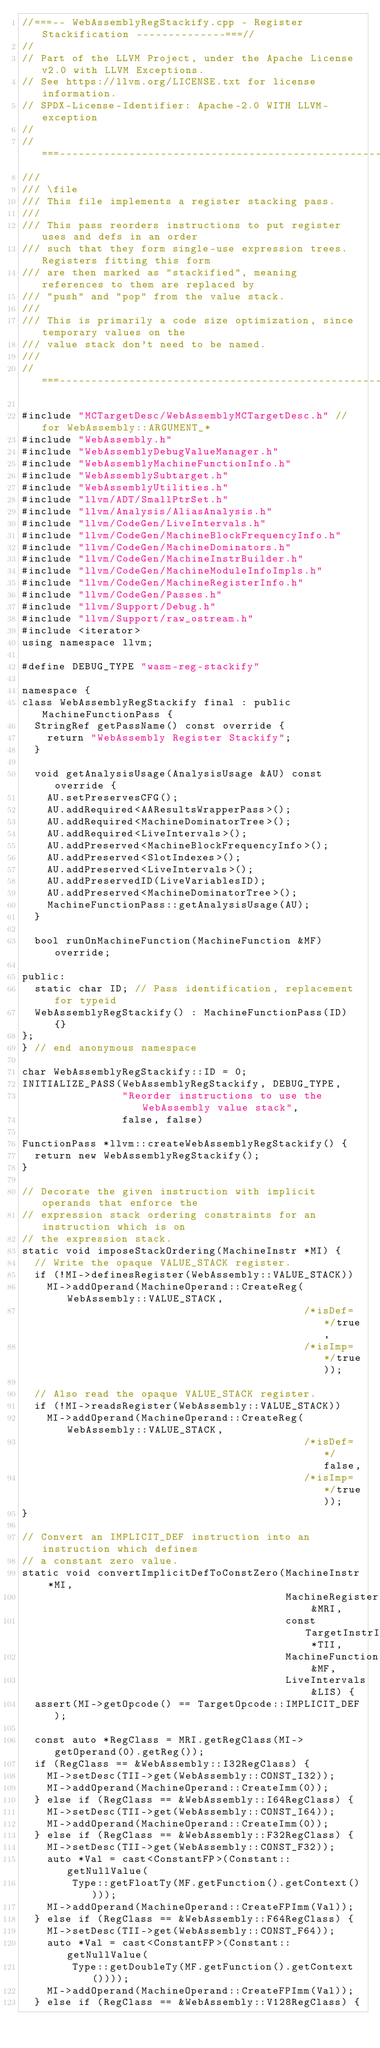Convert code to text. <code><loc_0><loc_0><loc_500><loc_500><_C++_>//===-- WebAssemblyRegStackify.cpp - Register Stackification --------------===//
//
// Part of the LLVM Project, under the Apache License v2.0 with LLVM Exceptions.
// See https://llvm.org/LICENSE.txt for license information.
// SPDX-License-Identifier: Apache-2.0 WITH LLVM-exception
//
//===----------------------------------------------------------------------===//
///
/// \file
/// This file implements a register stacking pass.
///
/// This pass reorders instructions to put register uses and defs in an order
/// such that they form single-use expression trees. Registers fitting this form
/// are then marked as "stackified", meaning references to them are replaced by
/// "push" and "pop" from the value stack.
///
/// This is primarily a code size optimization, since temporary values on the
/// value stack don't need to be named.
///
//===----------------------------------------------------------------------===//

#include "MCTargetDesc/WebAssemblyMCTargetDesc.h" // for WebAssembly::ARGUMENT_*
#include "WebAssembly.h"
#include "WebAssemblyDebugValueManager.h"
#include "WebAssemblyMachineFunctionInfo.h"
#include "WebAssemblySubtarget.h"
#include "WebAssemblyUtilities.h"
#include "llvm/ADT/SmallPtrSet.h"
#include "llvm/Analysis/AliasAnalysis.h"
#include "llvm/CodeGen/LiveIntervals.h"
#include "llvm/CodeGen/MachineBlockFrequencyInfo.h"
#include "llvm/CodeGen/MachineDominators.h"
#include "llvm/CodeGen/MachineInstrBuilder.h"
#include "llvm/CodeGen/MachineModuleInfoImpls.h"
#include "llvm/CodeGen/MachineRegisterInfo.h"
#include "llvm/CodeGen/Passes.h"
#include "llvm/Support/Debug.h"
#include "llvm/Support/raw_ostream.h"
#include <iterator>
using namespace llvm;

#define DEBUG_TYPE "wasm-reg-stackify"

namespace {
class WebAssemblyRegStackify final : public MachineFunctionPass {
  StringRef getPassName() const override {
    return "WebAssembly Register Stackify";
  }

  void getAnalysisUsage(AnalysisUsage &AU) const override {
    AU.setPreservesCFG();
    AU.addRequired<AAResultsWrapperPass>();
    AU.addRequired<MachineDominatorTree>();
    AU.addRequired<LiveIntervals>();
    AU.addPreserved<MachineBlockFrequencyInfo>();
    AU.addPreserved<SlotIndexes>();
    AU.addPreserved<LiveIntervals>();
    AU.addPreservedID(LiveVariablesID);
    AU.addPreserved<MachineDominatorTree>();
    MachineFunctionPass::getAnalysisUsage(AU);
  }

  bool runOnMachineFunction(MachineFunction &MF) override;

public:
  static char ID; // Pass identification, replacement for typeid
  WebAssemblyRegStackify() : MachineFunctionPass(ID) {}
};
} // end anonymous namespace

char WebAssemblyRegStackify::ID = 0;
INITIALIZE_PASS(WebAssemblyRegStackify, DEBUG_TYPE,
                "Reorder instructions to use the WebAssembly value stack",
                false, false)

FunctionPass *llvm::createWebAssemblyRegStackify() {
  return new WebAssemblyRegStackify();
}

// Decorate the given instruction with implicit operands that enforce the
// expression stack ordering constraints for an instruction which is on
// the expression stack.
static void imposeStackOrdering(MachineInstr *MI) {
  // Write the opaque VALUE_STACK register.
  if (!MI->definesRegister(WebAssembly::VALUE_STACK))
    MI->addOperand(MachineOperand::CreateReg(WebAssembly::VALUE_STACK,
                                             /*isDef=*/true,
                                             /*isImp=*/true));

  // Also read the opaque VALUE_STACK register.
  if (!MI->readsRegister(WebAssembly::VALUE_STACK))
    MI->addOperand(MachineOperand::CreateReg(WebAssembly::VALUE_STACK,
                                             /*isDef=*/false,
                                             /*isImp=*/true));
}

// Convert an IMPLICIT_DEF instruction into an instruction which defines
// a constant zero value.
static void convertImplicitDefToConstZero(MachineInstr *MI,
                                          MachineRegisterInfo &MRI,
                                          const TargetInstrInfo *TII,
                                          MachineFunction &MF,
                                          LiveIntervals &LIS) {
  assert(MI->getOpcode() == TargetOpcode::IMPLICIT_DEF);

  const auto *RegClass = MRI.getRegClass(MI->getOperand(0).getReg());
  if (RegClass == &WebAssembly::I32RegClass) {
    MI->setDesc(TII->get(WebAssembly::CONST_I32));
    MI->addOperand(MachineOperand::CreateImm(0));
  } else if (RegClass == &WebAssembly::I64RegClass) {
    MI->setDesc(TII->get(WebAssembly::CONST_I64));
    MI->addOperand(MachineOperand::CreateImm(0));
  } else if (RegClass == &WebAssembly::F32RegClass) {
    MI->setDesc(TII->get(WebAssembly::CONST_F32));
    auto *Val = cast<ConstantFP>(Constant::getNullValue(
        Type::getFloatTy(MF.getFunction().getContext())));
    MI->addOperand(MachineOperand::CreateFPImm(Val));
  } else if (RegClass == &WebAssembly::F64RegClass) {
    MI->setDesc(TII->get(WebAssembly::CONST_F64));
    auto *Val = cast<ConstantFP>(Constant::getNullValue(
        Type::getDoubleTy(MF.getFunction().getContext())));
    MI->addOperand(MachineOperand::CreateFPImm(Val));
  } else if (RegClass == &WebAssembly::V128RegClass) {</code> 